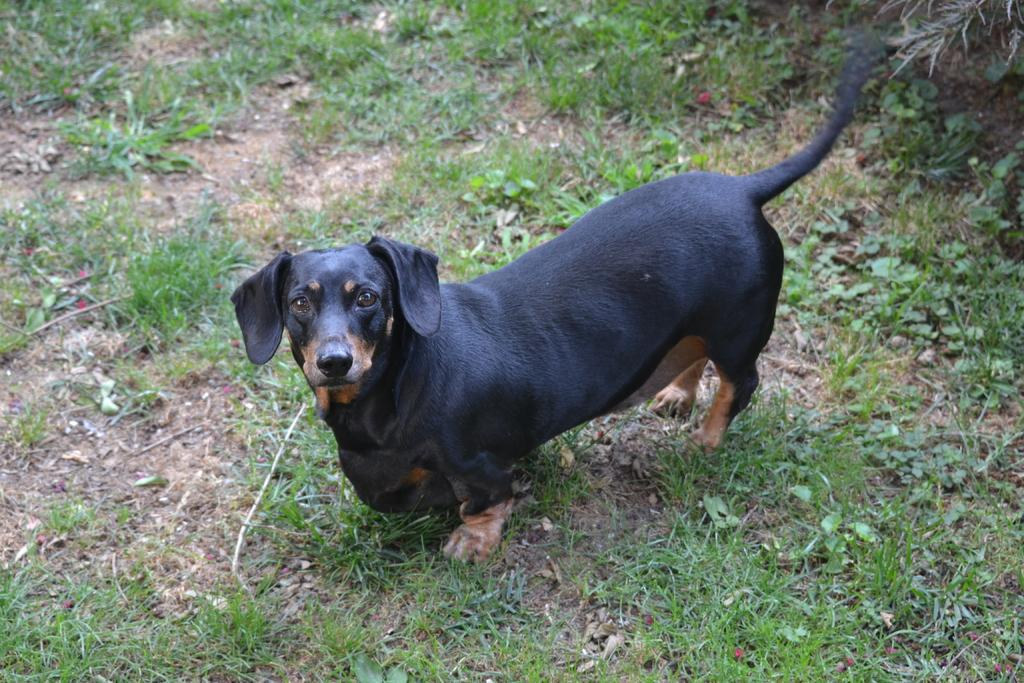What type of animal is in the image? There is a dog in the image. What color is the dog? The dog is black in color. What type of environment is visible in the image? There is grass visible in the image. What type of pancake is the dog eating in the image? There is no pancake present in the image, and the dog is not eating anything. 